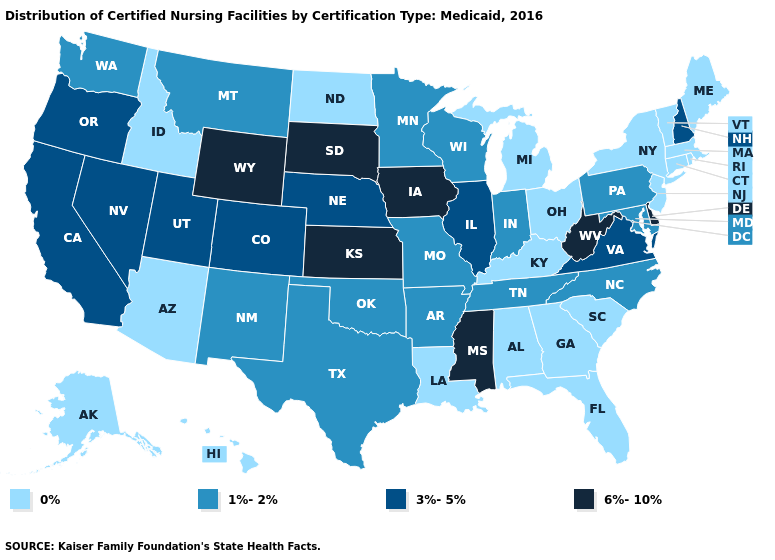What is the lowest value in states that border Michigan?
Be succinct. 0%. Name the states that have a value in the range 6%-10%?
Short answer required. Delaware, Iowa, Kansas, Mississippi, South Dakota, West Virginia, Wyoming. How many symbols are there in the legend?
Quick response, please. 4. What is the highest value in states that border Utah?
Concise answer only. 6%-10%. Does North Carolina have a lower value than New Jersey?
Quick response, please. No. What is the value of Hawaii?
Answer briefly. 0%. What is the value of Florida?
Quick response, please. 0%. What is the value of Oregon?
Give a very brief answer. 3%-5%. How many symbols are there in the legend?
Write a very short answer. 4. Which states have the lowest value in the Northeast?
Write a very short answer. Connecticut, Maine, Massachusetts, New Jersey, New York, Rhode Island, Vermont. How many symbols are there in the legend?
Write a very short answer. 4. Does Maine have the lowest value in the Northeast?
Keep it brief. Yes. Name the states that have a value in the range 6%-10%?
Concise answer only. Delaware, Iowa, Kansas, Mississippi, South Dakota, West Virginia, Wyoming. Which states have the lowest value in the USA?
Write a very short answer. Alabama, Alaska, Arizona, Connecticut, Florida, Georgia, Hawaii, Idaho, Kentucky, Louisiana, Maine, Massachusetts, Michigan, New Jersey, New York, North Dakota, Ohio, Rhode Island, South Carolina, Vermont. Which states hav the highest value in the MidWest?
Quick response, please. Iowa, Kansas, South Dakota. 